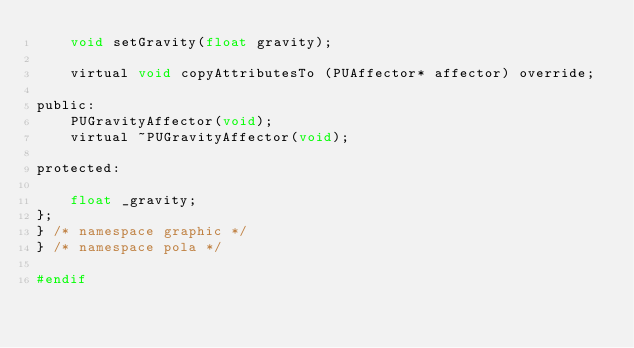<code> <loc_0><loc_0><loc_500><loc_500><_C_>    void setGravity(float gravity);

    virtual void copyAttributesTo (PUAffector* affector) override;

public:
    PUGravityAffector(void);
    virtual ~PUGravityAffector(void);

protected:

    float _gravity;
};
} /* namespace graphic */
} /* namespace pola */

#endif
</code> 